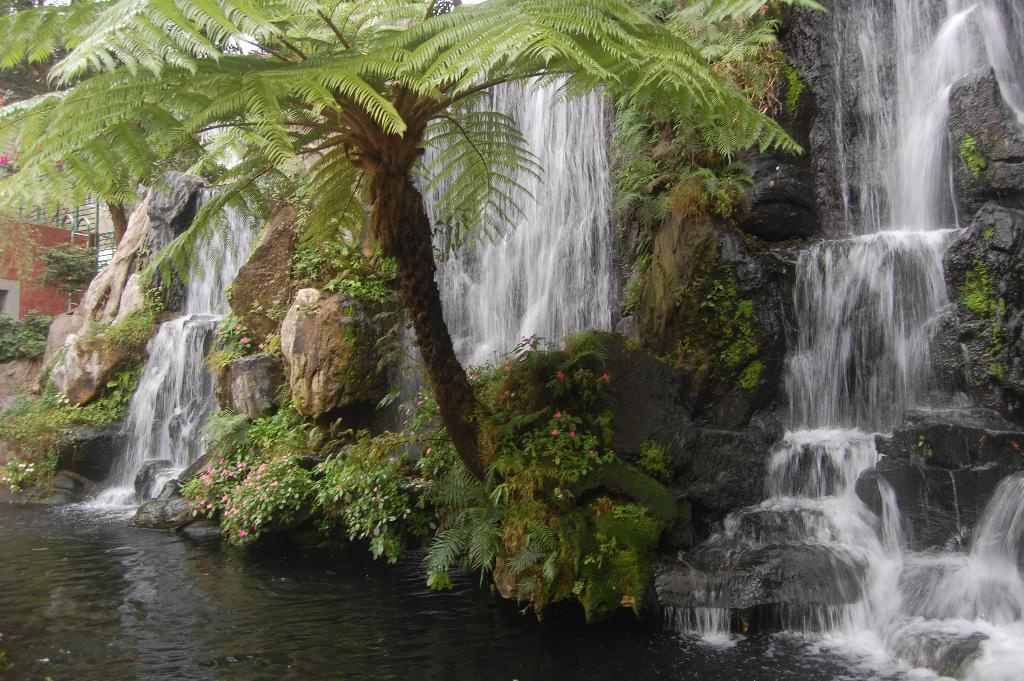What natural feature is the main subject of the image? There is a waterfall in the image. What other elements can be seen in the image besides the waterfall? There are plants, a tree, and rocks in the image. What type of whip is being used to control the weather in the image? There is no whip or indication of weather control present in the image. 